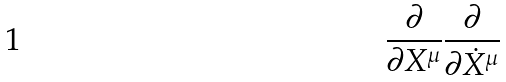Convert formula to latex. <formula><loc_0><loc_0><loc_500><loc_500>\frac { \partial } { \partial X ^ { \mu } } \frac { \partial } { \partial \dot { X } ^ { \mu } }</formula> 